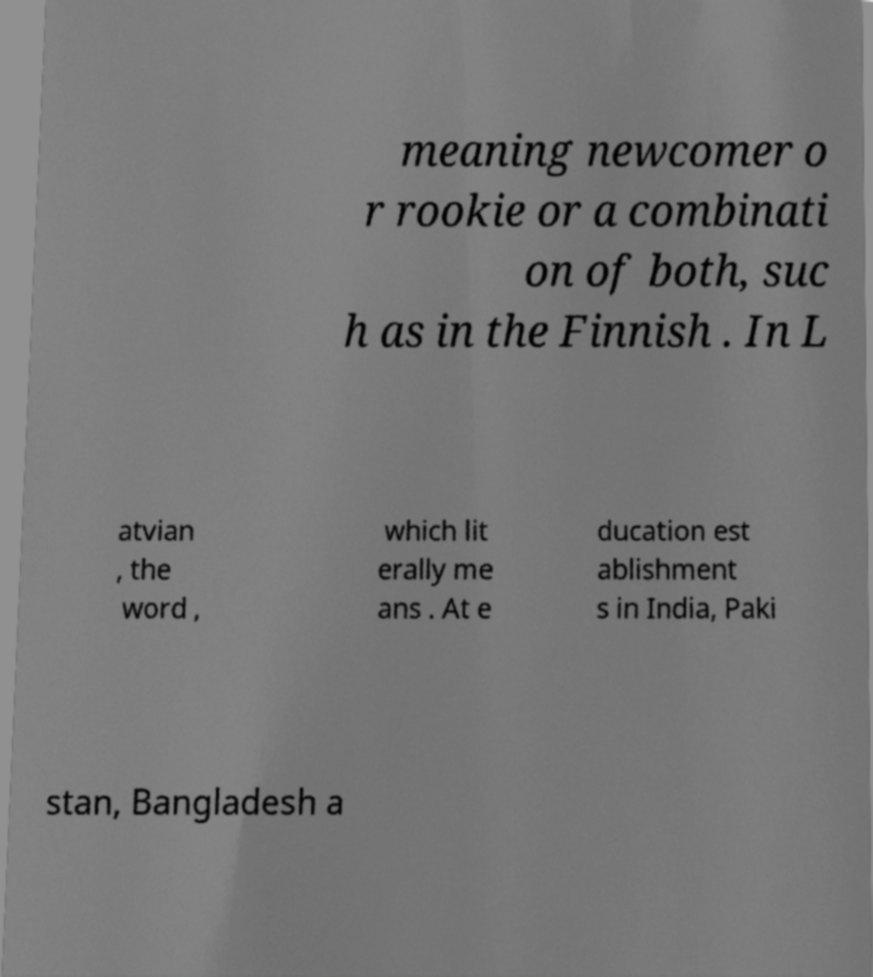There's text embedded in this image that I need extracted. Can you transcribe it verbatim? meaning newcomer o r rookie or a combinati on of both, suc h as in the Finnish . In L atvian , the word , which lit erally me ans . At e ducation est ablishment s in India, Paki stan, Bangladesh a 